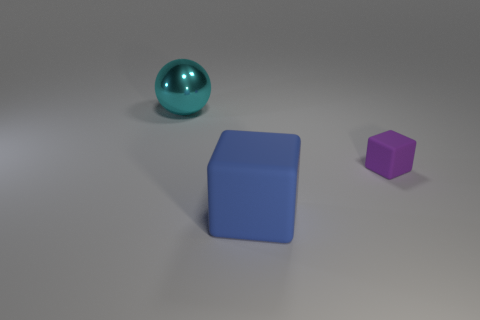Subtract 1 blocks. How many blocks are left? 1 Subtract all purple cubes. Subtract all purple cylinders. How many cubes are left? 1 Subtract all blue balls. How many purple blocks are left? 1 Subtract all blue cubes. Subtract all gray rubber blocks. How many objects are left? 2 Add 2 small purple blocks. How many small purple blocks are left? 3 Add 2 tiny purple shiny cubes. How many tiny purple shiny cubes exist? 2 Add 2 tiny matte objects. How many objects exist? 5 Subtract 1 purple cubes. How many objects are left? 2 Subtract all cubes. How many objects are left? 1 